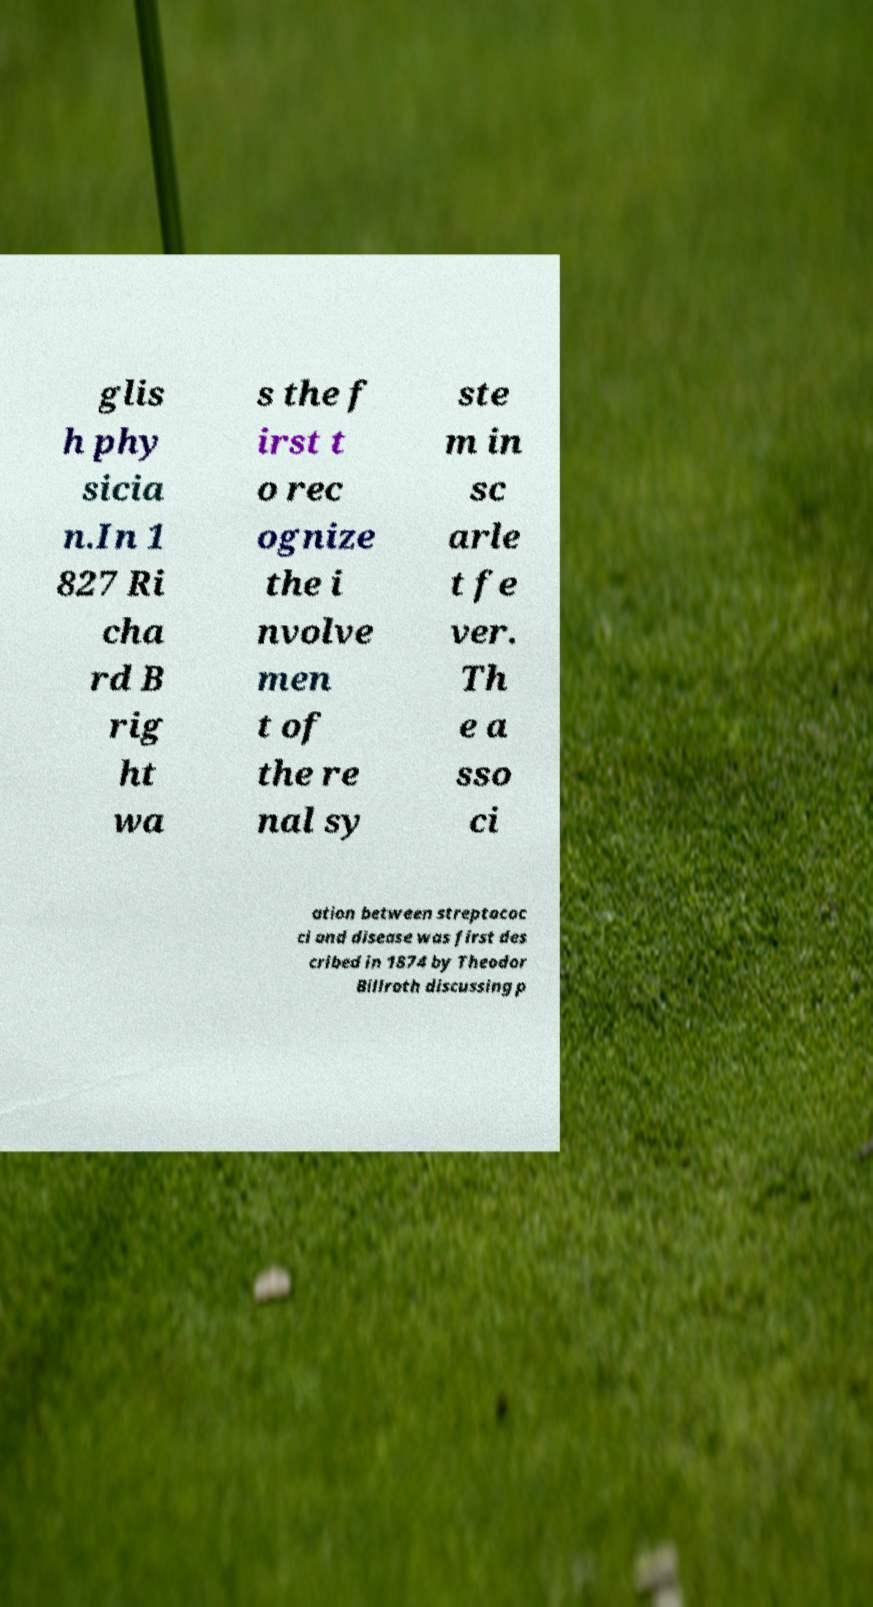Please read and relay the text visible in this image. What does it say? glis h phy sicia n.In 1 827 Ri cha rd B rig ht wa s the f irst t o rec ognize the i nvolve men t of the re nal sy ste m in sc arle t fe ver. Th e a sso ci ation between streptococ ci and disease was first des cribed in 1874 by Theodor Billroth discussing p 